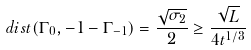<formula> <loc_0><loc_0><loc_500><loc_500>d i s t ( \Gamma _ { 0 } , - 1 - \Gamma _ { - 1 } ) = \frac { \sqrt { \sigma _ { 2 } } } { 2 } \geq \frac { \sqrt { L } } { 4 t ^ { 1 / 3 } }</formula> 